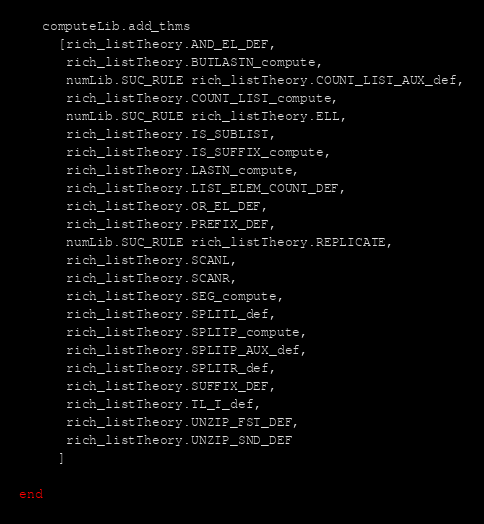Convert code to text. <code><loc_0><loc_0><loc_500><loc_500><_SML_>   computeLib.add_thms
     [rich_listTheory.AND_EL_DEF,
      rich_listTheory.BUTLASTN_compute,
      numLib.SUC_RULE rich_listTheory.COUNT_LIST_AUX_def,
      rich_listTheory.COUNT_LIST_compute,
      numLib.SUC_RULE rich_listTheory.ELL,
      rich_listTheory.IS_SUBLIST,
      rich_listTheory.IS_SUFFIX_compute,
      rich_listTheory.LASTN_compute,
      rich_listTheory.LIST_ELEM_COUNT_DEF,
      rich_listTheory.OR_EL_DEF,
      rich_listTheory.PREFIX_DEF,
      numLib.SUC_RULE rich_listTheory.REPLICATE,
      rich_listTheory.SCANL,
      rich_listTheory.SCANR,
      rich_listTheory.SEG_compute,
      rich_listTheory.SPLITL_def,
      rich_listTheory.SPLITP_compute,
      rich_listTheory.SPLITP_AUX_def,
      rich_listTheory.SPLITR_def,
      rich_listTheory.SUFFIX_DEF,
      rich_listTheory.TL_T_def,
      rich_listTheory.UNZIP_FST_DEF,
      rich_listTheory.UNZIP_SND_DEF
     ]

end
</code> 